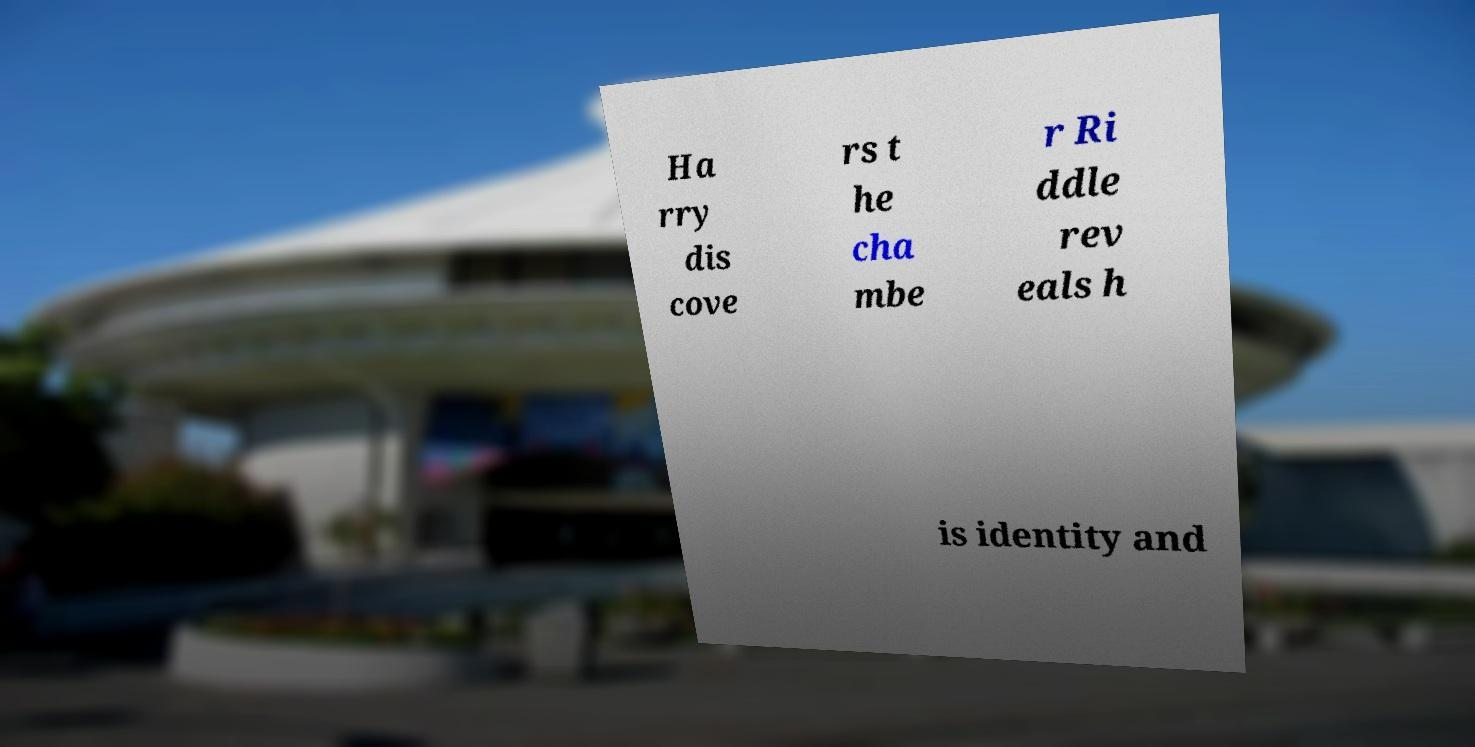Please read and relay the text visible in this image. What does it say? Ha rry dis cove rs t he cha mbe r Ri ddle rev eals h is identity and 